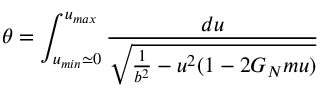Convert formula to latex. <formula><loc_0><loc_0><loc_500><loc_500>\theta = \int _ { u _ { \min } \simeq 0 } ^ { u _ { \max } } { \frac { d u } { \sqrt { { \frac { 1 } { b ^ { 2 } } } - u ^ { 2 } ( 1 - 2 G _ { N } m u ) } } }</formula> 